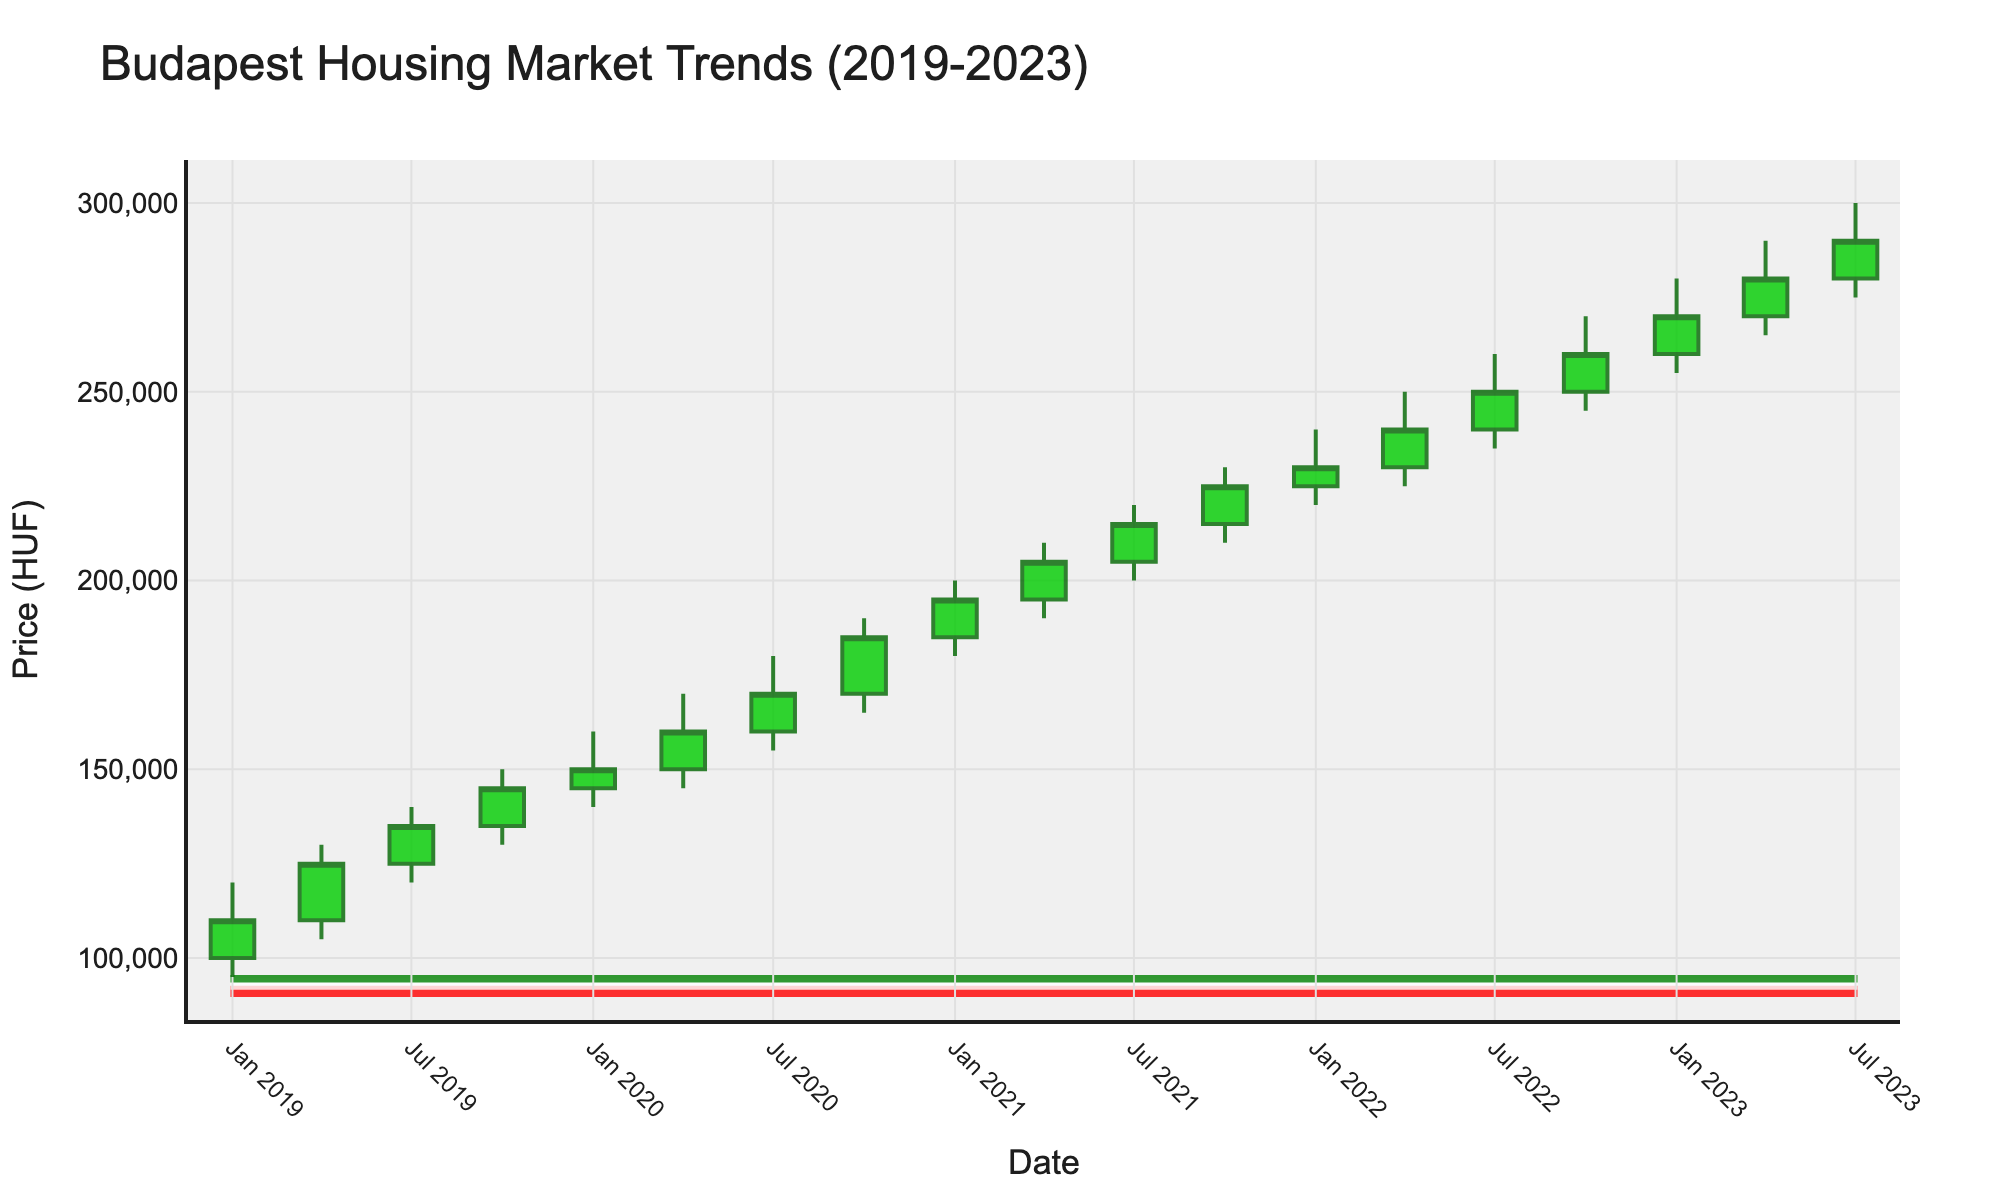What is the highest price recorded in the Budapest housing market over the past 5 years? The highest price can be found by looking at the highest value on the Y-axis. The plot shows the highest price recorded was 300,000 HUF.
Answer: 300,000 HUF Between which dates did the housing price first exceed 200,000 HUF? To find when the price first exceeded 200,000 HUF, observe the candlestick where the closing price first surpasses 200,000 HUF. This happens between January 2021 and April 2021.
Answer: January 2021 to April 2021 How many data points are there in the figure? Each candlestick represents a data point. By counting the number of candlesticks, you can find there are 20 data points, representing each quarter from January 2019 to July 2023.
Answer: 20 What was the price range (difference between the highest and lowest prices) in the first quarter of 2023? For January 2023, the highest price is 280,000 HUF and the lowest price is 255,000 HUF. Subtracting the lowest price from the highest price gives 25,000 HUF.
Answer: 25,000 HUF During which quarter was there the smallest difference between the high and low prices, and what was this difference? To find the smallest difference, calculate the difference between the high and low prices for each quarter and compare them. The smallest difference occurs in October 2019, where the high was 150,000 HUF and the low was 130,000 HUF, resulting in a difference of 20,000 HUF.
Answer: October 2019, 20,000 HUF What is the overall trend in housing prices from January 2019 to July 2023? Observing the overall pattern of the candlesticks, the prices have been consistently increasing from January 2019 to July 2023. The opening and closing prices of each quarter gradually rise.
Answer: Increasing In which quarter did the closing price first equal the opening price of the next quarter? Review the closing and subsequent opening prices to find the match. The closing price of January 2020 (150,000 HUF) equals the opening price of April 2020 (150,000 HUF).
Answer: January 2020 to April 2020 Which quarter had the maximum increase from its opening to its closing price? The quarter with the largest difference between its closing and opening prices is January 2021, where the price increased from 185,000 HUF to 195,000 HUF, a gain of 10,000 HUF.
Answer: January 2021 What is the median closing price over the entire period? To find the median, list all the closing prices and find the middle value. The sorted closing prices are: 110,000, 125,000, 135,000, 145,000, 150,000, 160,000, 170,000, 185,000, 195,000, 205,000, 215,000, 225,000, 230,000, 240,000, 250,000, 260,000, 270,000, 280,000, 290,000. The median is the middle value of this sorted list, which is 215,000 HUF.
Answer: 215,000 HUF 